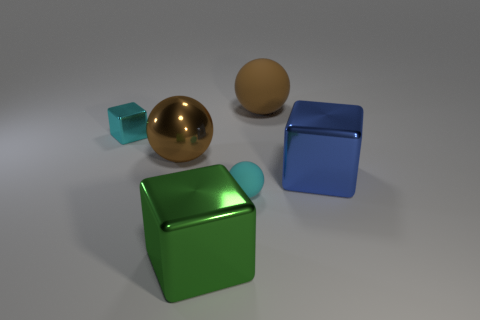There is a metal object that is to the left of the large metal thing behind the blue block; what number of brown objects are in front of it? In front of the large, reflective gold sphere positioned to the left of the green metal cube, there is only one brown sphere present. 